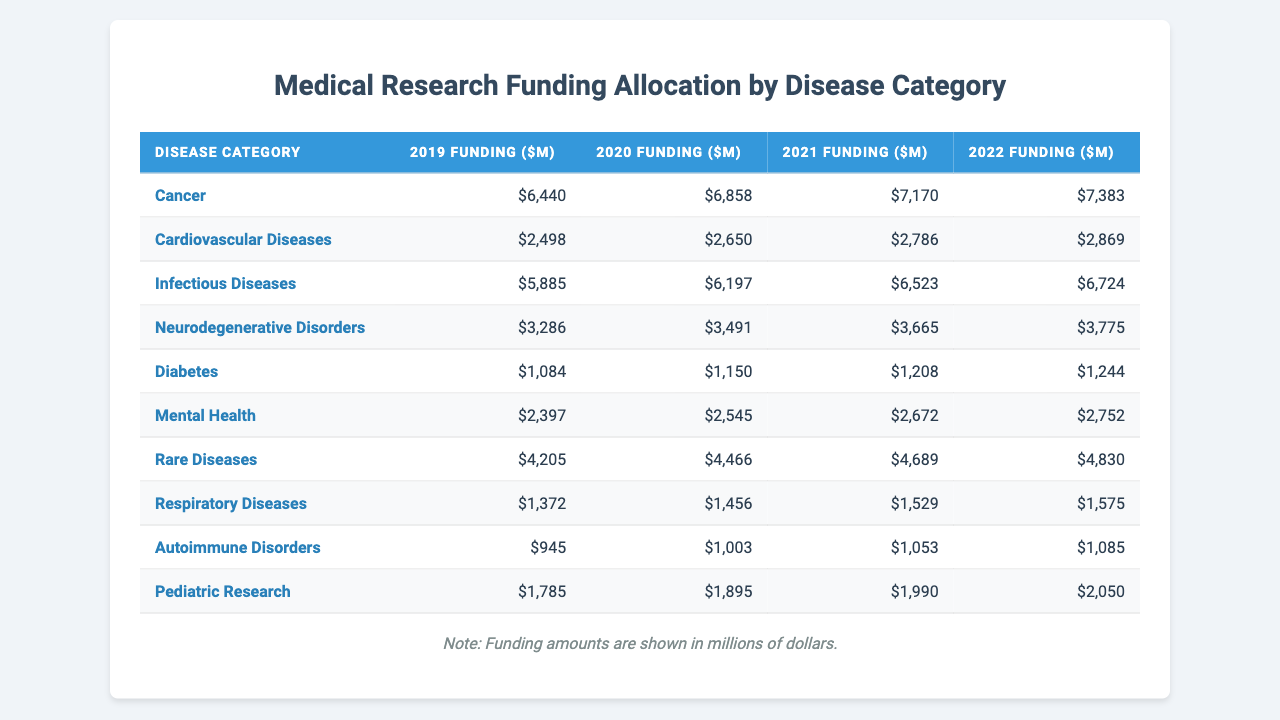What was the total funding for Cancer research from 2019 to 2022? To find the total funding, we sum the annual funding amounts for Cancer over the four years. So, 6440 + 6858 + 7170 + 7383 = 29851 million dollars.
Answer: 29851 million dollars Which disease category received the highest funding in 2022? In 2022, the funding for each disease category is as follows: Cancer (7383), Infectious Diseases (6724), Cardiovascular Diseases (2869), and so on. The highest is Cancer with 7383 million dollars.
Answer: Cancer What is the average funding for Diabetes over the four years? We add the funding amounts for Diabetes: 1084 + 1150 + 1208 + 1244 = 4686 million dollars. Then, divide by 4 (the number of years), which gives us 4686 / 4 = 1171.5 million dollars.
Answer: 1171.5 million dollars Did funding for Neurodegenerative Disorders increase every year from 2019 to 2022? The funding amounts for Neurodegenerative Disorders are: 3286 in 2019, 3491 in 2020, 3665 in 2021, and 3775 in 2022. Since each year shows an increase from the previous year, the answer is yes.
Answer: Yes What is the total funding difference between Autoimmune Disorders and Respiratory Diseases in 2021? Funding for Autoimmune Disorders in 2021 is 1053 million dollars and for Respiratory Diseases is 1529 million dollars. The difference is 1529 - 1053 = 476 million dollars.
Answer: 476 million dollars Which disease category had the least funding in 2019? By reviewing the funding amounts in 2019, the values are: Cancer (6440), Cardiovascular Diseases (2498), Infectious Diseases (5885), and so on. The minimum is for Autoimmune Disorders at 945 million dollars.
Answer: Autoimmune Disorders What was the percentage increase in funding for Mental Health from 2019 to 2022? The funding for Mental Health in 2019 was 2397 million dollars and in 2022 it was 2752 million dollars. The increase is 2752 - 2397 = 355 million dollars. To find the percentage increase, we calculate (355 / 2397) * 100, which gives approximately 14.8%.
Answer: 14.8% If funding for Rare Diseases continued to grow at the same rate as from 2021 to 2022, what would the estimated funding be in 2023? The funding for Rare Diseases increased from 4689 million dollars in 2021 to 4830 million dollars in 2022, an increase of 141 million dollars. If we add this increase to the 2022 funding, we estimate 4830 + 141 = 4971 million dollars for 2023.
Answer: 4971 million dollars Which disease category had a funding amount of over 6000 million dollars in 2020? The funding amounts in 2020 are: Cancer (6858), Infectious Diseases (6197), Cardiovascular Diseases (2650), and so on. Cancer and Infectious Diseases exceeded 6000 million dollars.
Answer: Cancer and Infectious Diseases What is the total funding allocated to all categories in 2020? The total funding for 2020 sums as follows: Cancer (6858), Cardiovascular Diseases (2650), Infectious Diseases (6197), Neurodegenerative Disorders (3491), Diabetes (1150), Mental Health (2545), Rare Diseases (4466), Respiratory Diseases (1456), Autoimmune Disorders (1003), and Pediatric Research (1895). Adding these gives a total of 24366 million dollars.
Answer: 24366 million dollars 